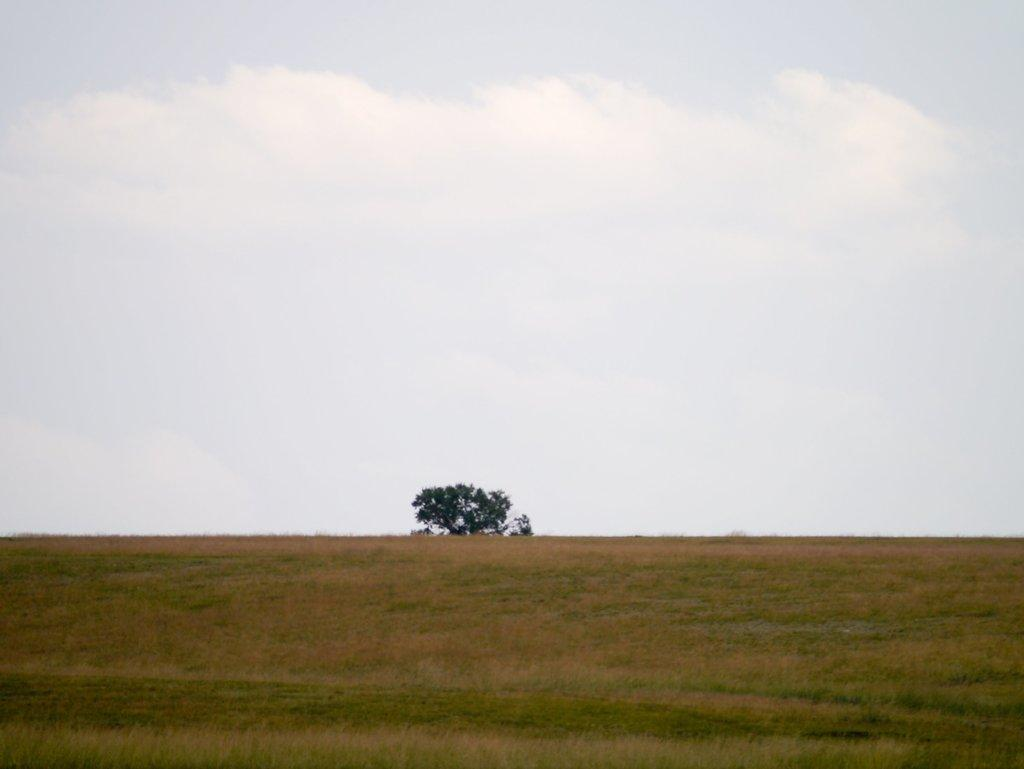What type of vegetation is present in the image? There is a tree in the image. What is the main feature of the landscape in the image? There is a grass field in the image. What can be seen in the background of the image? The sky is visible in the background of the image. How would you describe the weather based on the sky in the image? The sky appears to be cloudy in the image. What type of pie is being discussed in the image? There is no pie or discussion present in the image. How many cars can be seen driving through the grass field in the image? There are no cars visible in the image; it features a tree, a grass field, and a cloudy sky. 